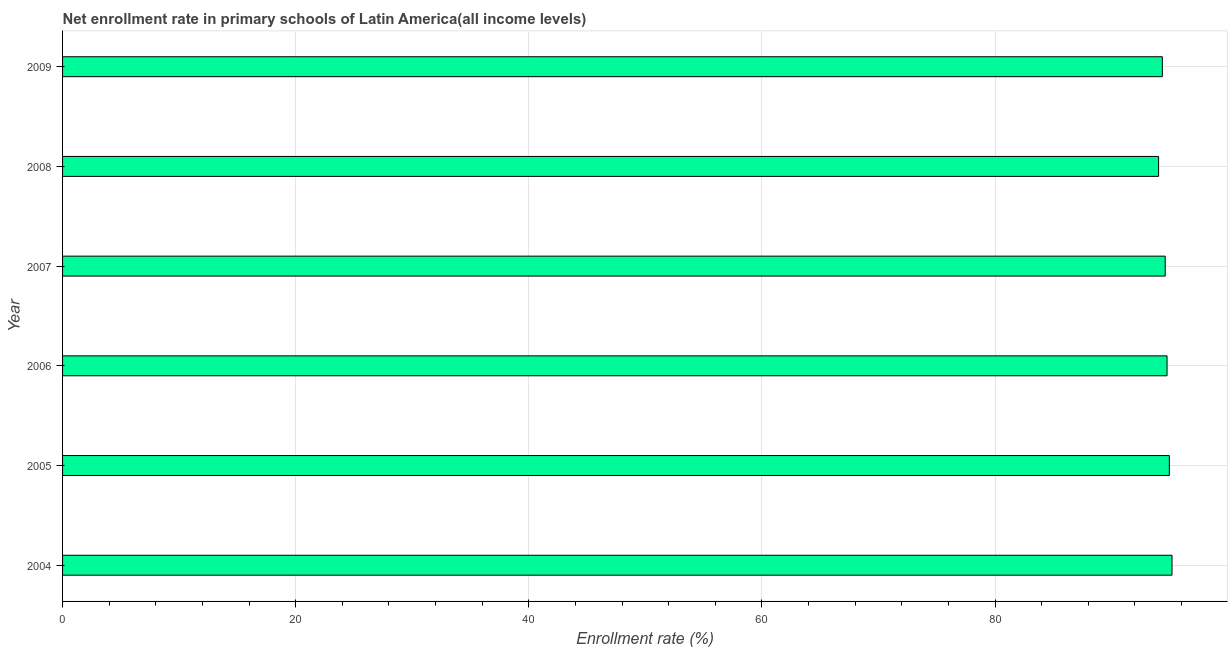Does the graph contain grids?
Your answer should be compact. Yes. What is the title of the graph?
Ensure brevity in your answer.  Net enrollment rate in primary schools of Latin America(all income levels). What is the label or title of the X-axis?
Your answer should be compact. Enrollment rate (%). What is the label or title of the Y-axis?
Ensure brevity in your answer.  Year. What is the net enrollment rate in primary schools in 2005?
Offer a very short reply. 94.95. Across all years, what is the maximum net enrollment rate in primary schools?
Provide a succinct answer. 95.18. Across all years, what is the minimum net enrollment rate in primary schools?
Provide a short and direct response. 94.03. In which year was the net enrollment rate in primary schools maximum?
Keep it short and to the point. 2004. In which year was the net enrollment rate in primary schools minimum?
Offer a terse response. 2008. What is the sum of the net enrollment rate in primary schools?
Provide a short and direct response. 567.84. What is the difference between the net enrollment rate in primary schools in 2007 and 2009?
Make the answer very short. 0.25. What is the average net enrollment rate in primary schools per year?
Keep it short and to the point. 94.64. What is the median net enrollment rate in primary schools?
Give a very brief answer. 94.67. Do a majority of the years between 2004 and 2005 (inclusive) have net enrollment rate in primary schools greater than 60 %?
Your response must be concise. Yes. Is the difference between the net enrollment rate in primary schools in 2007 and 2009 greater than the difference between any two years?
Your response must be concise. No. What is the difference between the highest and the second highest net enrollment rate in primary schools?
Your answer should be very brief. 0.23. What is the difference between the highest and the lowest net enrollment rate in primary schools?
Keep it short and to the point. 1.15. In how many years, is the net enrollment rate in primary schools greater than the average net enrollment rate in primary schools taken over all years?
Give a very brief answer. 3. Are all the bars in the graph horizontal?
Your response must be concise. Yes. How many years are there in the graph?
Your response must be concise. 6. Are the values on the major ticks of X-axis written in scientific E-notation?
Keep it short and to the point. No. What is the Enrollment rate (%) in 2004?
Offer a very short reply. 95.18. What is the Enrollment rate (%) in 2005?
Offer a very short reply. 94.95. What is the Enrollment rate (%) in 2006?
Your answer should be compact. 94.75. What is the Enrollment rate (%) in 2007?
Keep it short and to the point. 94.59. What is the Enrollment rate (%) of 2008?
Ensure brevity in your answer.  94.03. What is the Enrollment rate (%) in 2009?
Provide a short and direct response. 94.35. What is the difference between the Enrollment rate (%) in 2004 and 2005?
Your answer should be very brief. 0.23. What is the difference between the Enrollment rate (%) in 2004 and 2006?
Offer a terse response. 0.43. What is the difference between the Enrollment rate (%) in 2004 and 2007?
Your answer should be very brief. 0.58. What is the difference between the Enrollment rate (%) in 2004 and 2008?
Your answer should be compact. 1.15. What is the difference between the Enrollment rate (%) in 2004 and 2009?
Ensure brevity in your answer.  0.83. What is the difference between the Enrollment rate (%) in 2005 and 2006?
Give a very brief answer. 0.2. What is the difference between the Enrollment rate (%) in 2005 and 2007?
Your answer should be compact. 0.35. What is the difference between the Enrollment rate (%) in 2005 and 2008?
Your answer should be very brief. 0.92. What is the difference between the Enrollment rate (%) in 2005 and 2009?
Provide a succinct answer. 0.6. What is the difference between the Enrollment rate (%) in 2006 and 2007?
Provide a succinct answer. 0.16. What is the difference between the Enrollment rate (%) in 2006 and 2008?
Offer a very short reply. 0.73. What is the difference between the Enrollment rate (%) in 2006 and 2009?
Offer a very short reply. 0.4. What is the difference between the Enrollment rate (%) in 2007 and 2008?
Provide a succinct answer. 0.57. What is the difference between the Enrollment rate (%) in 2007 and 2009?
Your response must be concise. 0.25. What is the difference between the Enrollment rate (%) in 2008 and 2009?
Give a very brief answer. -0.32. What is the ratio of the Enrollment rate (%) in 2004 to that in 2005?
Your answer should be very brief. 1. What is the ratio of the Enrollment rate (%) in 2004 to that in 2009?
Your answer should be very brief. 1.01. What is the ratio of the Enrollment rate (%) in 2005 to that in 2007?
Provide a succinct answer. 1. What is the ratio of the Enrollment rate (%) in 2005 to that in 2008?
Offer a very short reply. 1.01. What is the ratio of the Enrollment rate (%) in 2005 to that in 2009?
Offer a terse response. 1.01. What is the ratio of the Enrollment rate (%) in 2006 to that in 2007?
Make the answer very short. 1. What is the ratio of the Enrollment rate (%) in 2006 to that in 2009?
Keep it short and to the point. 1. What is the ratio of the Enrollment rate (%) in 2007 to that in 2009?
Make the answer very short. 1. 